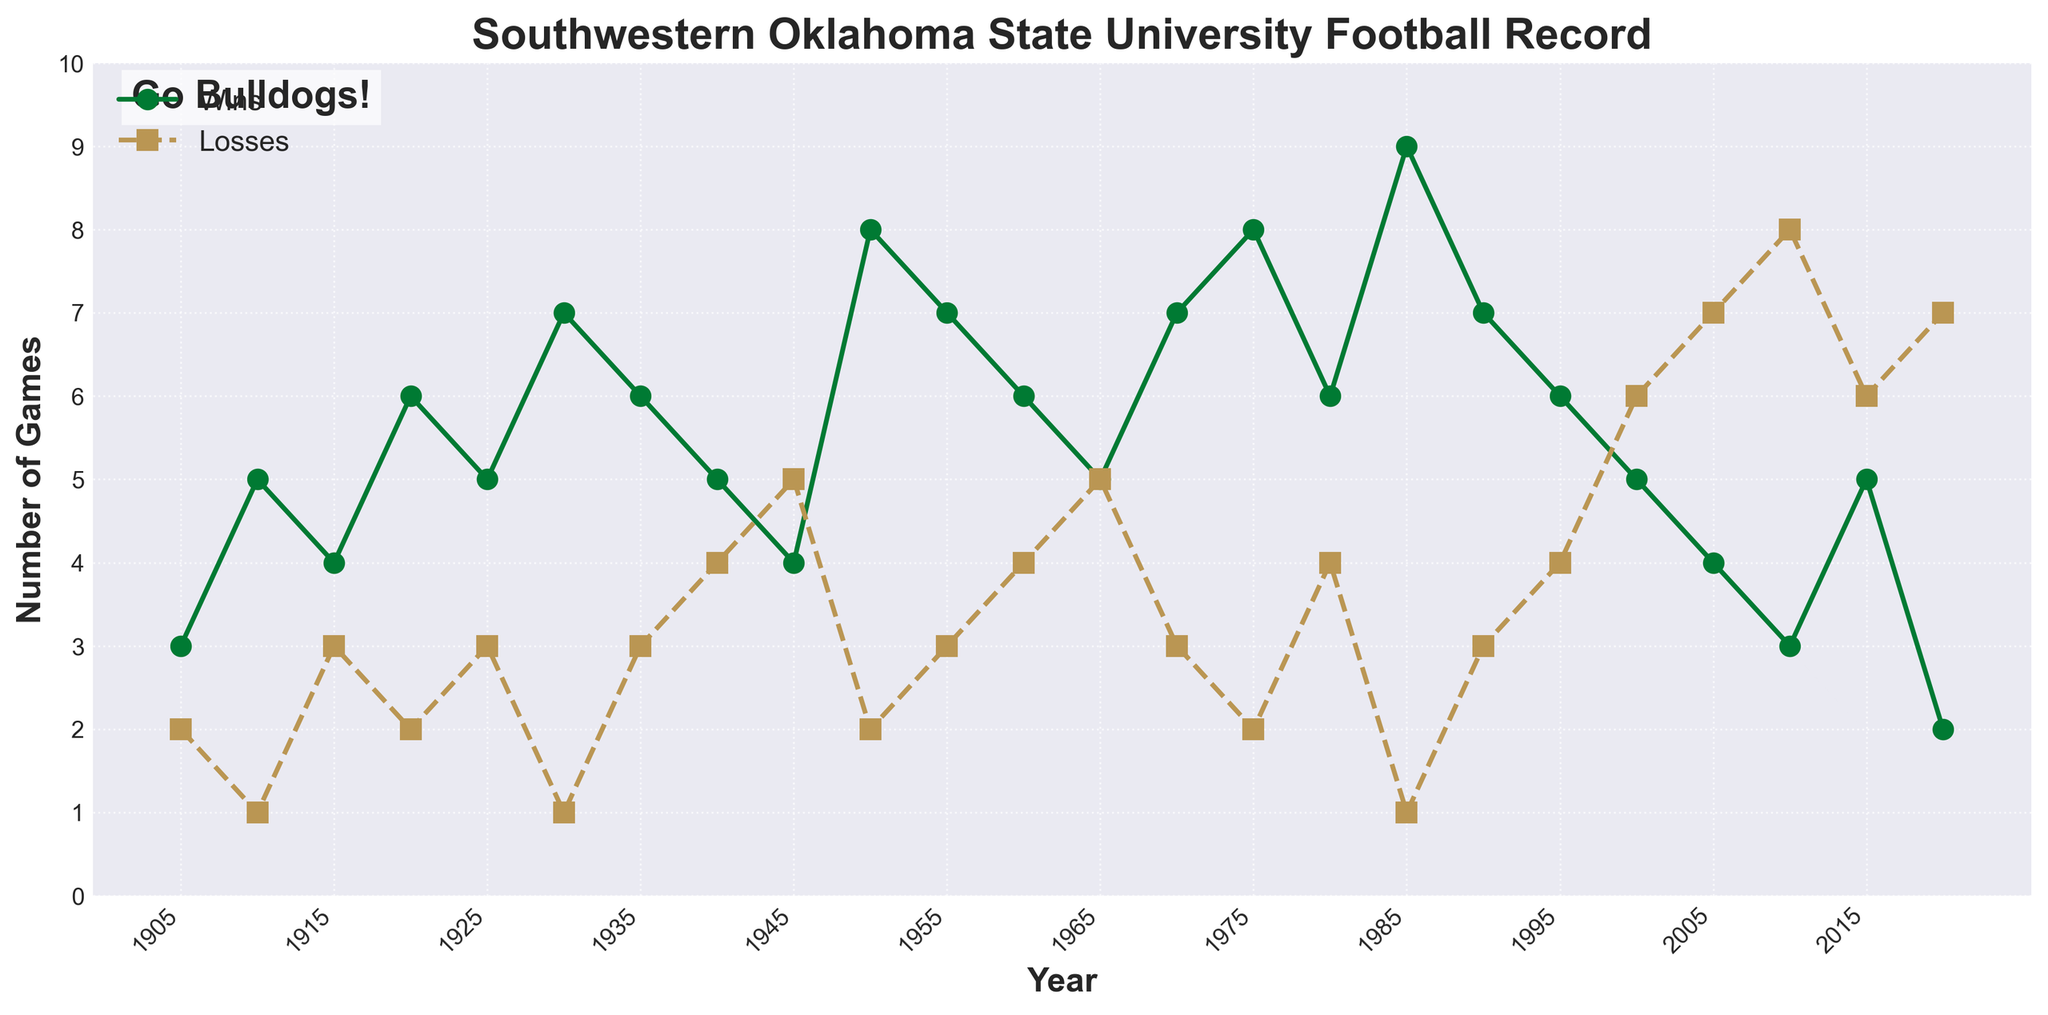What is the overall trend in the wins and losses from 1905 to 2020? Looking at the entire span from 1905 to 2020, observe the general direction of the win and loss lines. Wins show periods of increase and decrease but generally decline toward the end, while losses fluctuate but trend upwards more consistently.
Answer: Wins trend downwards, losses trend upwards How many times did the team win more than 7 games, and in which years? Identify the peaks in the wins line that exceed 7 wins. This occurs in 1930 (7 wins), 1950 (8 wins), 1975 (8 wins), and 1985 (9 wins). Count these instances.
Answer: Four times: 1930, 1950, 1975, 1985 Which year had the most wins, and how many? Look for the highest point on the wins line. This occurs in 1985 with 9 wins.
Answer: 1985, 9 wins Was there any year where the number of wins equaled the number of losses? Observe the points where the wins and losses lines intersect. This happens in 1965 (5 wins and 5 losses).
Answer: 1965 Which year saw the highest number of losses, and what was that number? Identify the highest point on the losses line. This occurs in 2010 with 8 losses.
Answer: 2010, 8 losses How many years did the team have more wins than losses? Count the instances where the number of wins is higher than the number of losses in the figure. The years are 1905, 1910, 1915, 1920, 1925, 1930, 1935, 1940, 1950, 1955, 1960, 1970, 1975, 1980, 1985, 1990, 1995. There are 17 years in total.
Answer: 17 years What was the largest margin of wins over losses in any given year? Calculate the differences between wins and losses for each year and find the maximum difference. This occurs in 1985 with a difference of 8 (9 wins, 1 loss).
Answer: 8 (in 1985) 